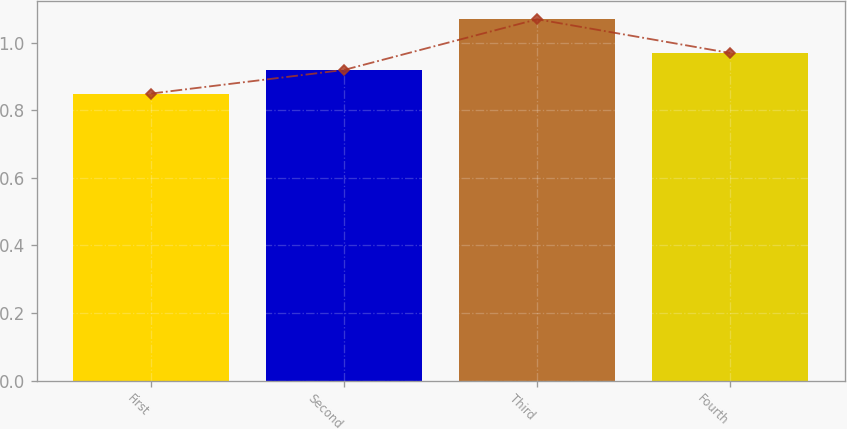<chart> <loc_0><loc_0><loc_500><loc_500><bar_chart><fcel>First<fcel>Second<fcel>Third<fcel>Fourth<nl><fcel>0.85<fcel>0.92<fcel>1.07<fcel>0.97<nl></chart> 